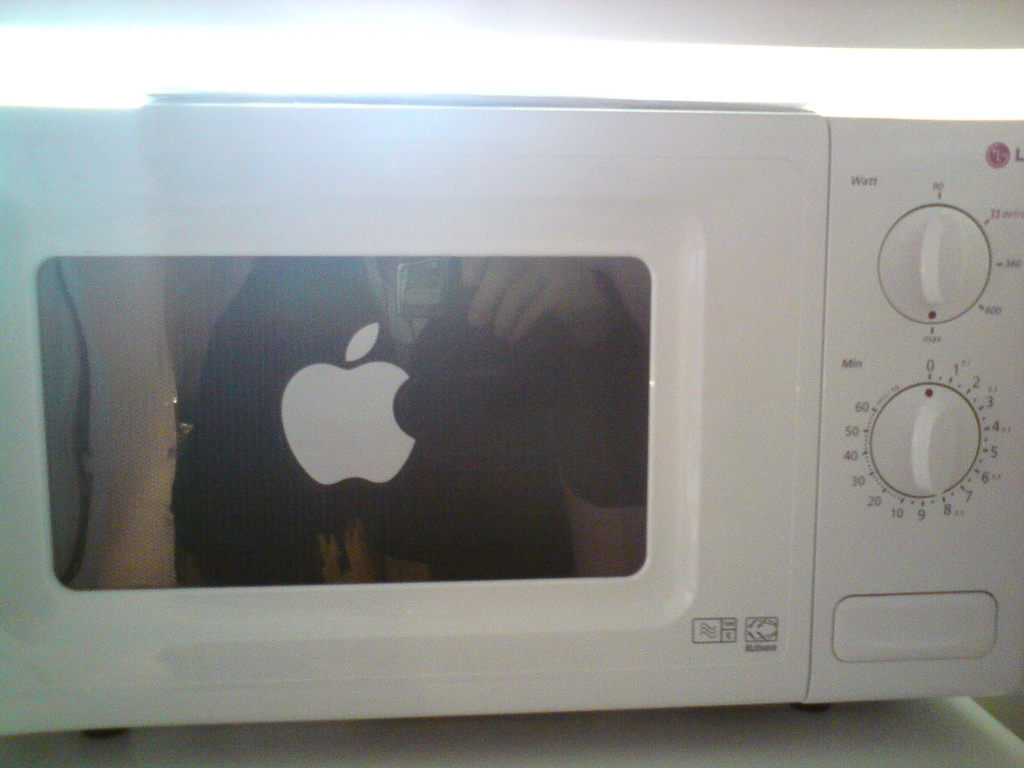What are some features you might expect in a microwave oven like this one? This LG microwave likely offers basic features such as adjustable power levels, a timer control, a defrost setting, and possibly a quick start or one-touch cooking option, judging by its simple dial controls. 